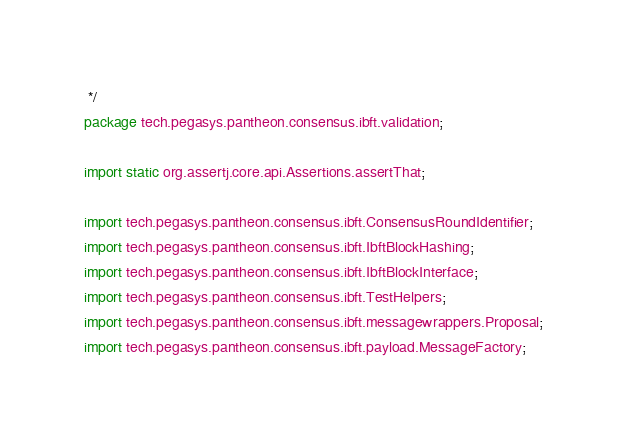<code> <loc_0><loc_0><loc_500><loc_500><_Java_> */
package tech.pegasys.pantheon.consensus.ibft.validation;

import static org.assertj.core.api.Assertions.assertThat;

import tech.pegasys.pantheon.consensus.ibft.ConsensusRoundIdentifier;
import tech.pegasys.pantheon.consensus.ibft.IbftBlockHashing;
import tech.pegasys.pantheon.consensus.ibft.IbftBlockInterface;
import tech.pegasys.pantheon.consensus.ibft.TestHelpers;
import tech.pegasys.pantheon.consensus.ibft.messagewrappers.Proposal;
import tech.pegasys.pantheon.consensus.ibft.payload.MessageFactory;</code> 